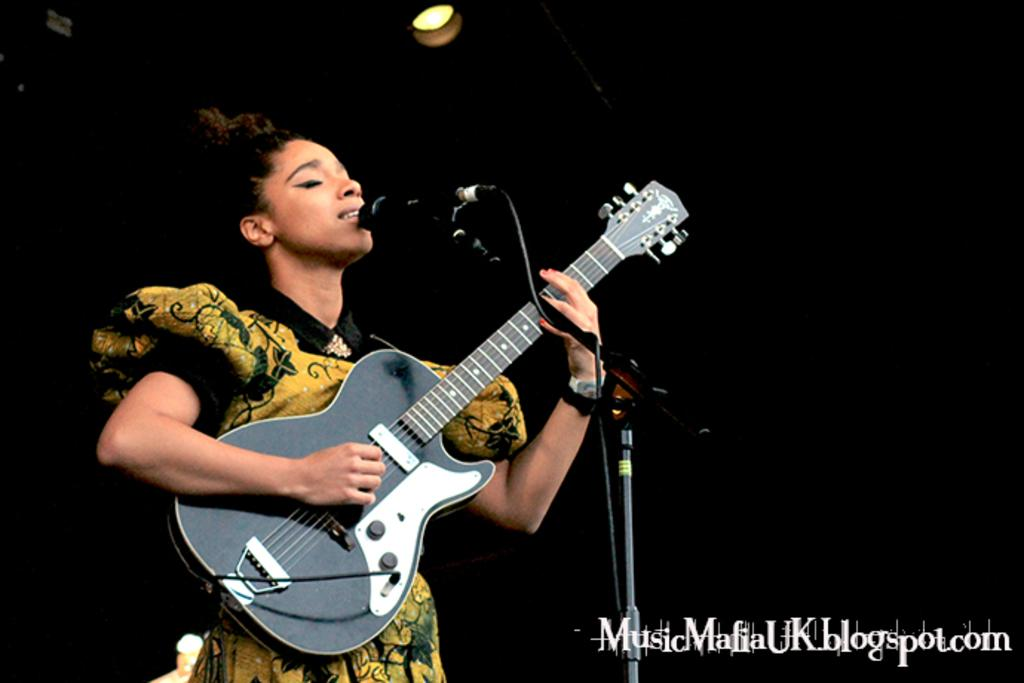What type of event is the image depicting? The image appears to be from a music show. What instrument is the woman holding in the image? The woman is holding a guitar in her hand. What is the woman doing in the image? The woman is singing a song. What color is the background of the image? The background of the image is completely black. Can you see any clover growing on the stage during the music show? There is no clover visible in the image, as the background is completely black and the focus is on the woman with the guitar. 